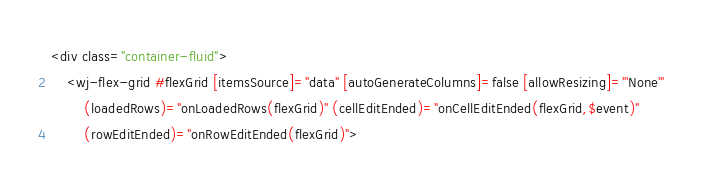Convert code to text. <code><loc_0><loc_0><loc_500><loc_500><_HTML_><div class="container-fluid">
    <wj-flex-grid #flexGrid [itemsSource]="data" [autoGenerateColumns]=false [allowResizing]="'None'"
        (loadedRows)="onLoadedRows(flexGrid)" (cellEditEnded)="onCellEditEnded(flexGrid,$event)"
        (rowEditEnded)="onRowEditEnded(flexGrid)"></code> 